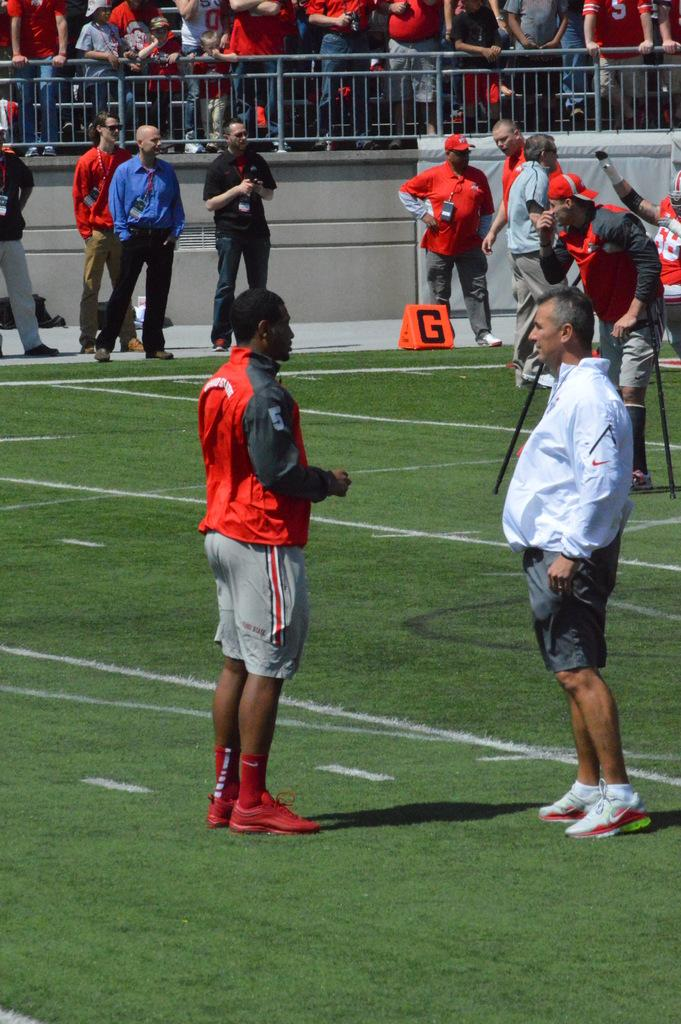What are the people in the image doing? There are people standing in the ground. Are there any other people in the image? Yes, there are other people standing behind a fence and watching the people in the ground. What page of the book are the people reading in the image? There is no book or page present in the image; it only shows people standing in the ground and others watching them from behind a fence. 